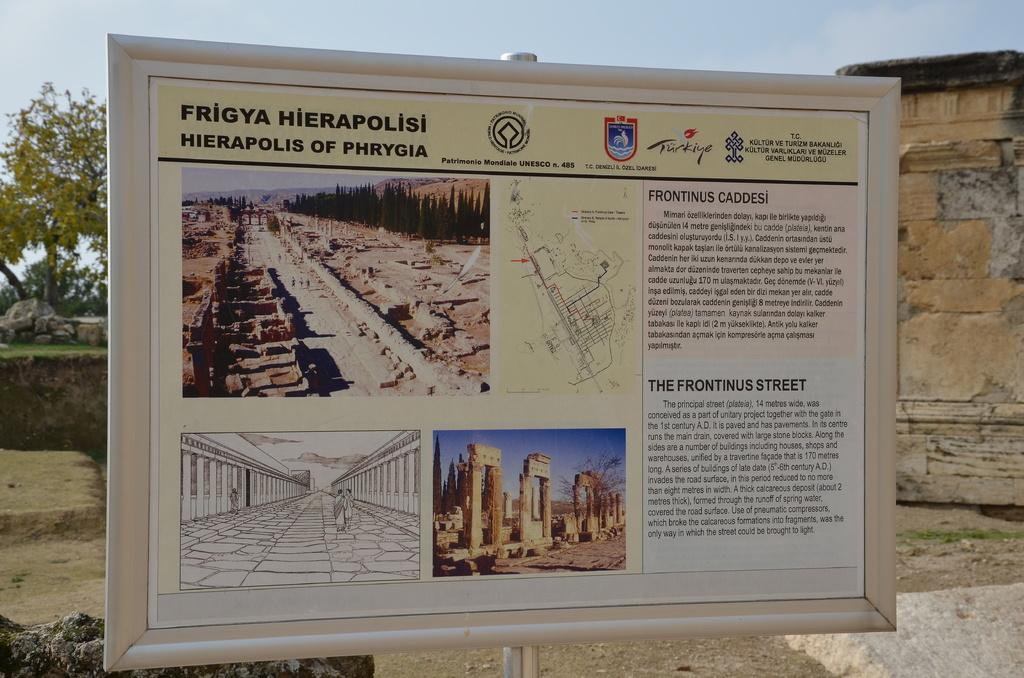<image>
Summarize the visual content of the image. a sign for ancient ruins of Hierapolis of Phrygia 